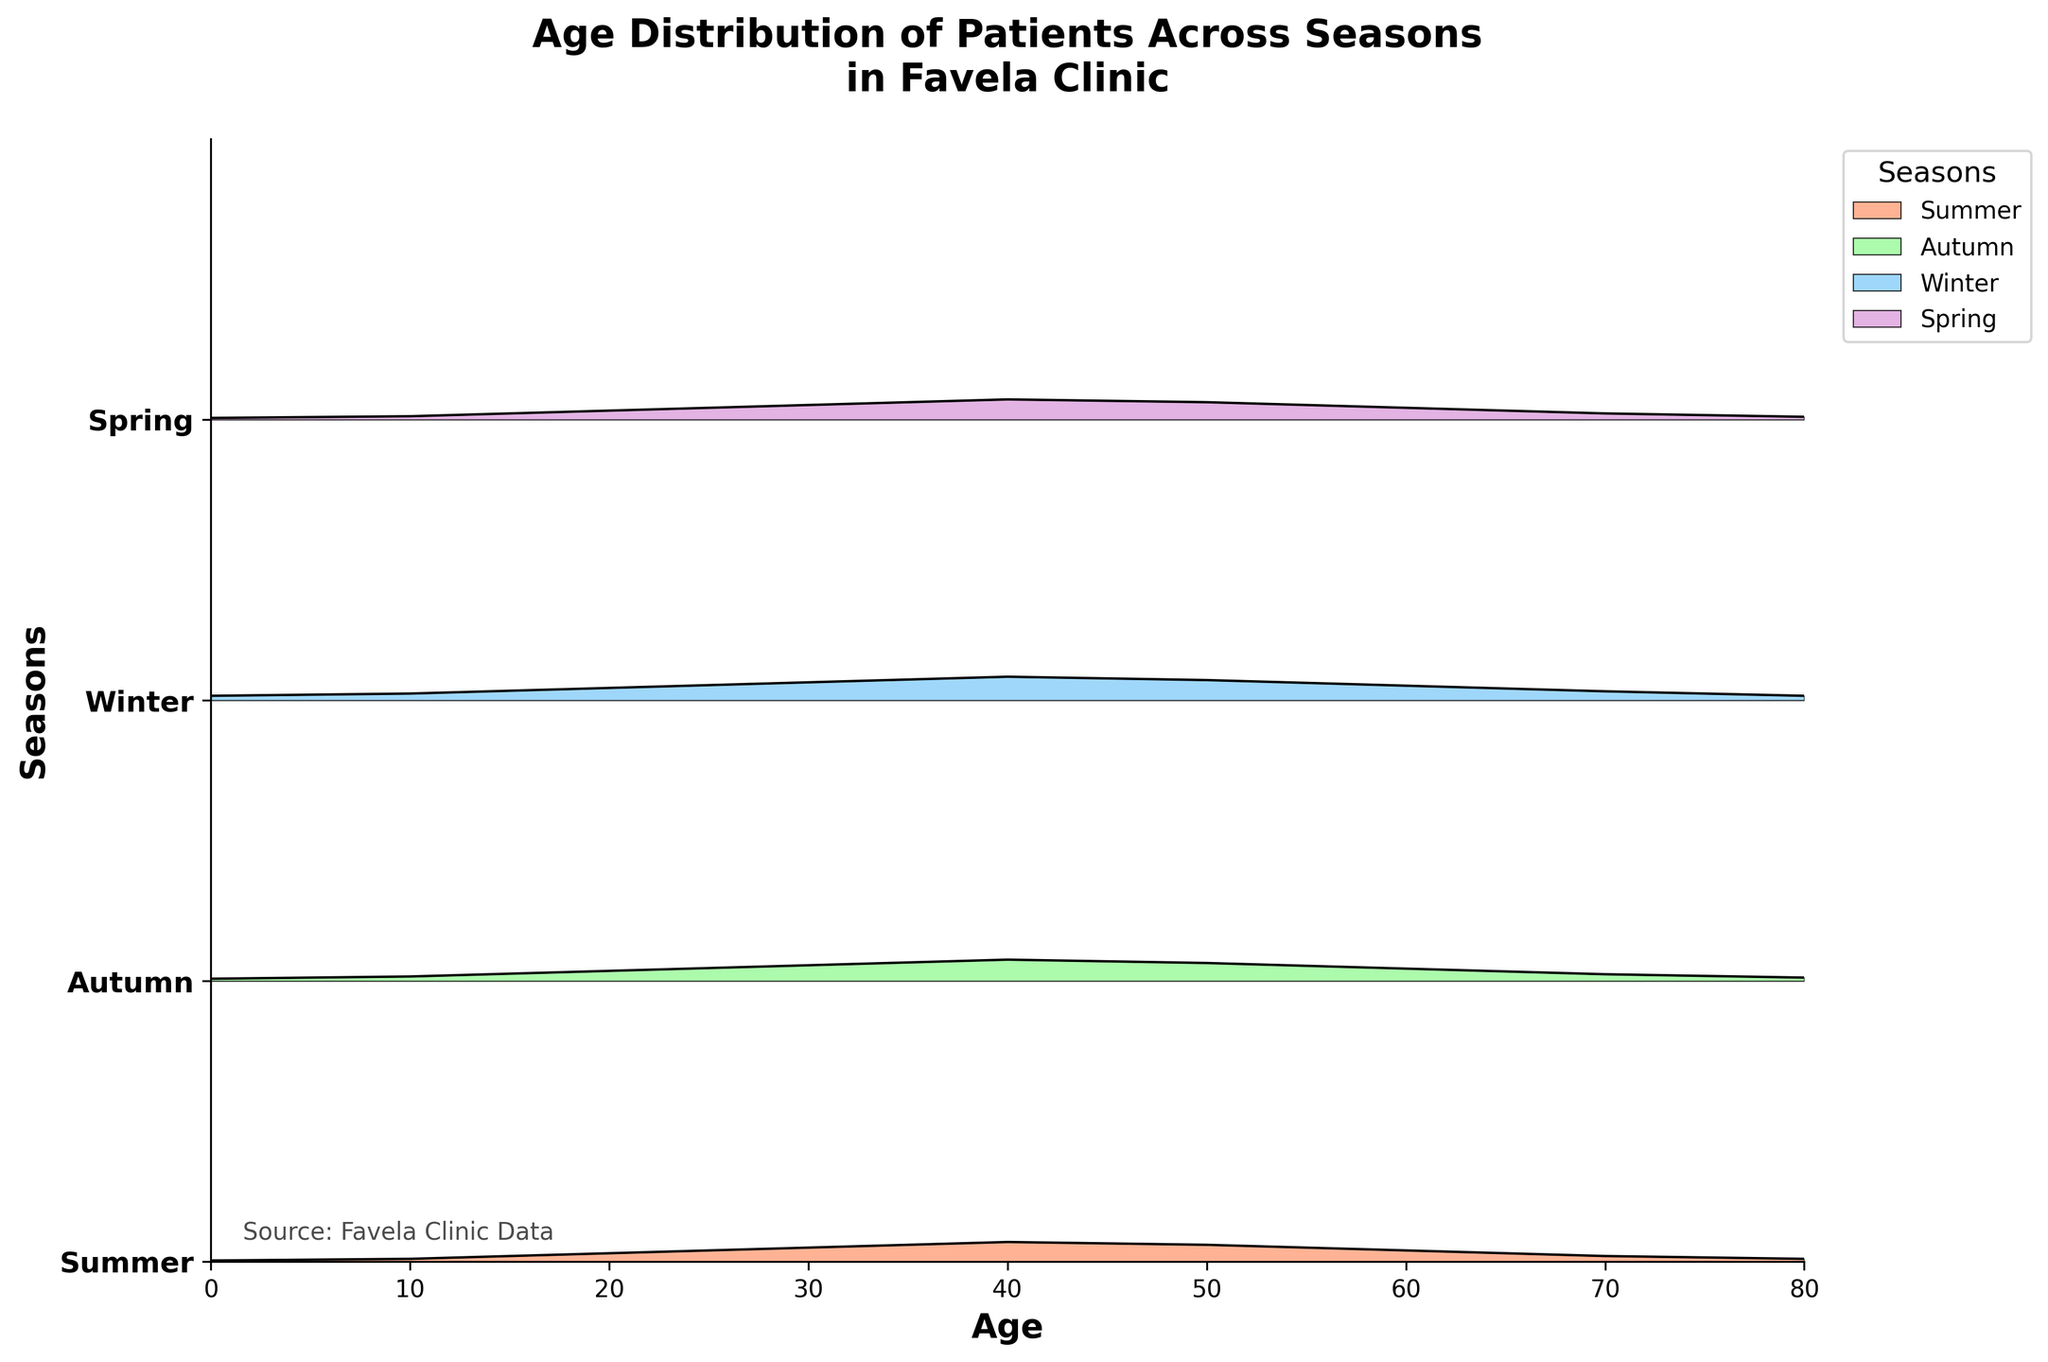How many seasons are displayed in the plot? There are four different sets of ridgelines that correspond to four unique seasons mentioned in the figure legend and the y-axis label.
Answer: 4 What is the age group with the highest density of seeking medical care during the winter? The peak density for Winter is observed around the age of 40, as indicated by the maximum height of the ridge for Winter on the plot.
Answer: 40 Which season shows the least density of patients aged 0? Comparing the heights of the ridgelines at age 0, Summer has the smallest height value.
Answer: Summer In which season do patients aged 50 show a density of 0.031? By comparing the densities for age 50 for each season's ridge, Spring has a density value of 0.031.
Answer: Spring Compare the density of patients aged 30 between Summer and Autumn. Which season has a higher density? The height of the ridgeline for Autumn at age 30 is higher than that for Summer, indicating a higher density.
Answer: Autumn What is the title of the ridgeline plot? The title is displayed at the top of the plot, specifying the topic of the visualization.
Answer: Age Distribution of Patients Across Seasons in Favela Clinic How does the density trend from age 0 to age 80 in each season? The density starts low at age 0, increases to a peak around ages 30-40, and then gradually decreases towards age 80 for all seasons.
Answer: Increase and then decrease Which season has the steepest drop after its peak density? After their peak densities, the gradient (slope) of the ridgeline from peak to the next age group shows that Winter has the steepest gradient (fastest drop).
Answer: Winter 